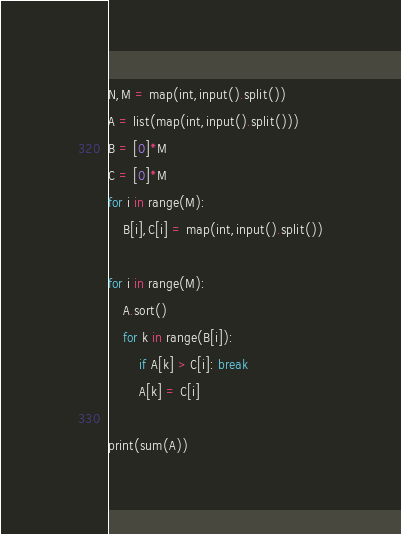Convert code to text. <code><loc_0><loc_0><loc_500><loc_500><_Python_>N,M = map(int,input().split())
A = list(map(int,input().split()))
B = [0]*M
C = [0]*M
for i in range(M):
    B[i],C[i] = map(int,input().split())
    
for i in range(M):
    A.sort()
    for k in range(B[i]):
        if A[k] > C[i]: break
        A[k] = C[i]

print(sum(A))</code> 